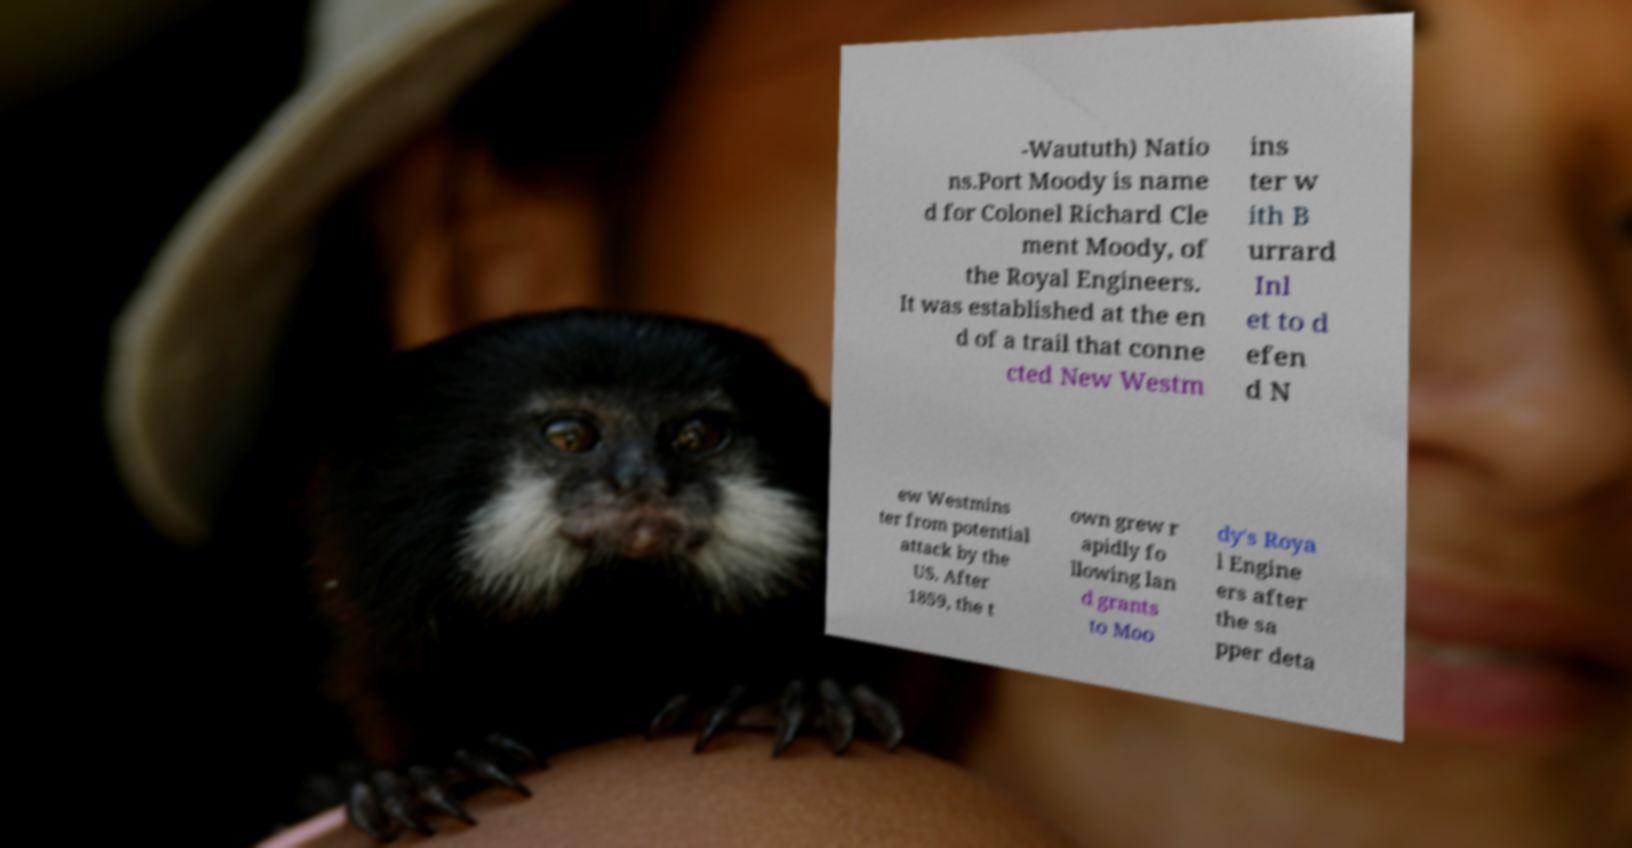Can you read and provide the text displayed in the image?This photo seems to have some interesting text. Can you extract and type it out for me? -Waututh) Natio ns.Port Moody is name d for Colonel Richard Cle ment Moody, of the Royal Engineers. It was established at the en d of a trail that conne cted New Westm ins ter w ith B urrard Inl et to d efen d N ew Westmins ter from potential attack by the US. After 1859, the t own grew r apidly fo llowing lan d grants to Moo dy's Roya l Engine ers after the sa pper deta 